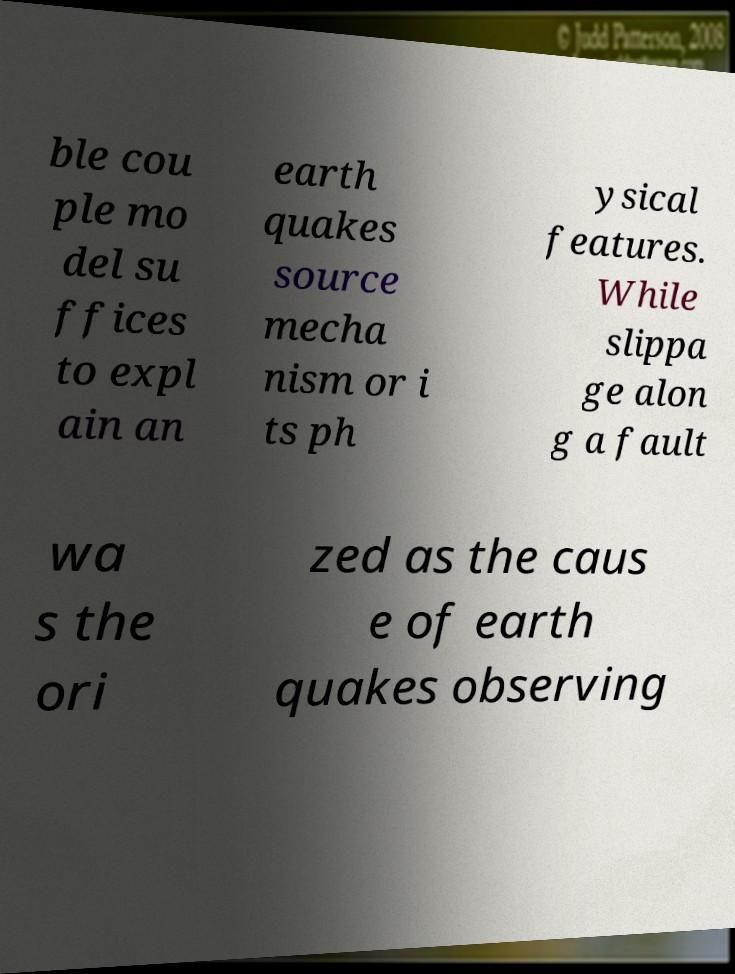Please read and relay the text visible in this image. What does it say? ble cou ple mo del su ffices to expl ain an earth quakes source mecha nism or i ts ph ysical features. While slippa ge alon g a fault wa s the ori zed as the caus e of earth quakes observing 